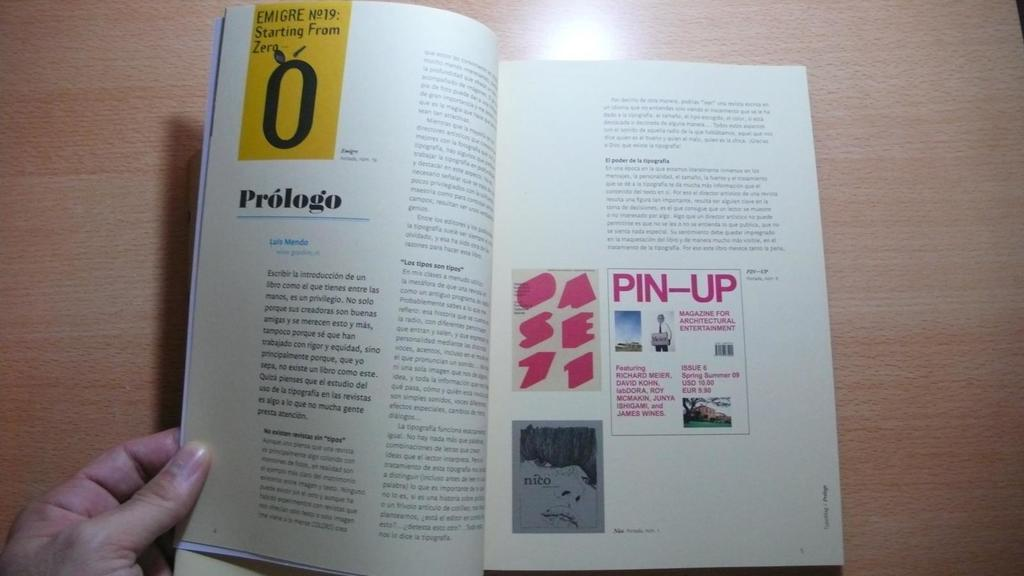<image>
Give a short and clear explanation of the subsequent image. Open book about Prologo and Luis Mendo with a pin up sign. 